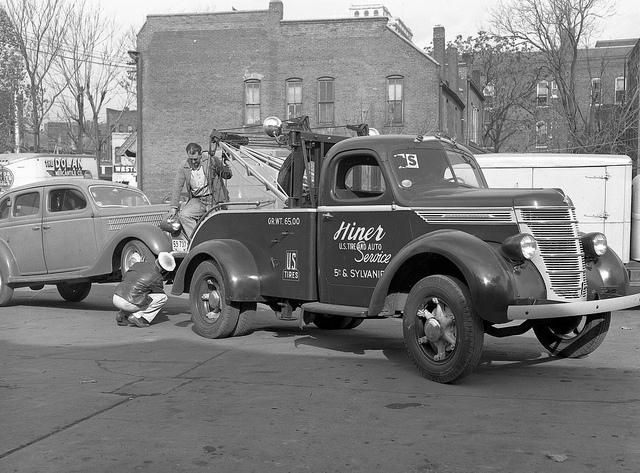Is someone driving the car?
Concise answer only. No. What type of engine does the truck on the left have?
Keep it brief. Gas. What is the name of the tow truck?
Answer briefly. Hiner. What type of emergency would this vehicle respond to?
Be succinct. Car accident. Is the truck loaded with people?
Quick response, please. No. How many men are there?
Quick response, please. 2. 